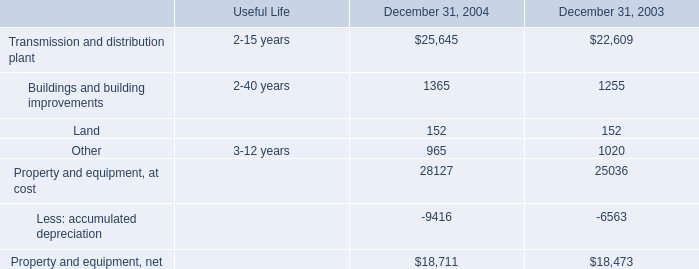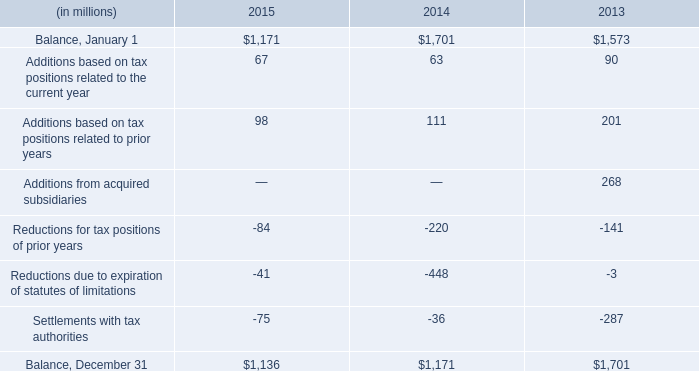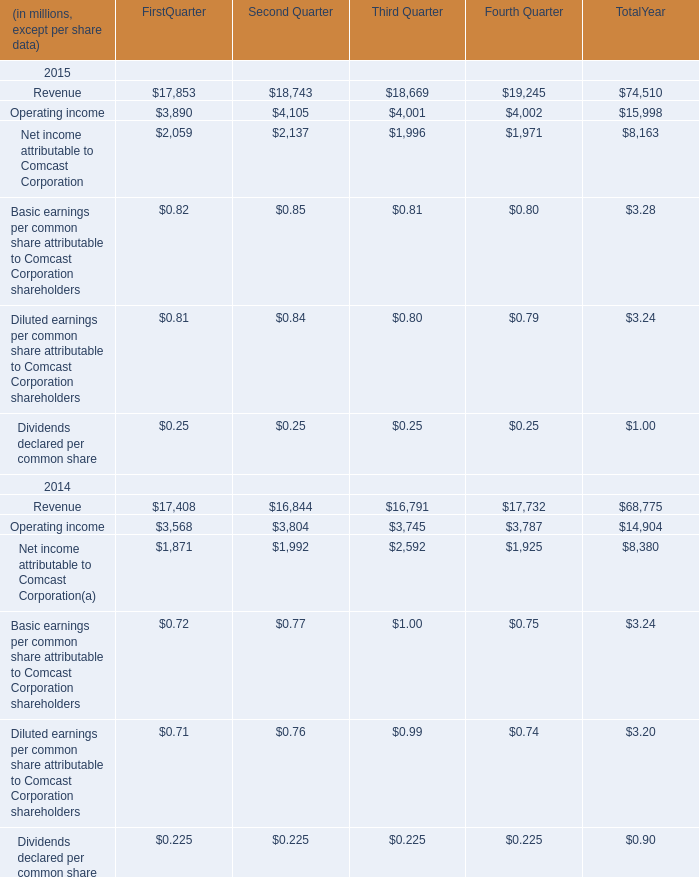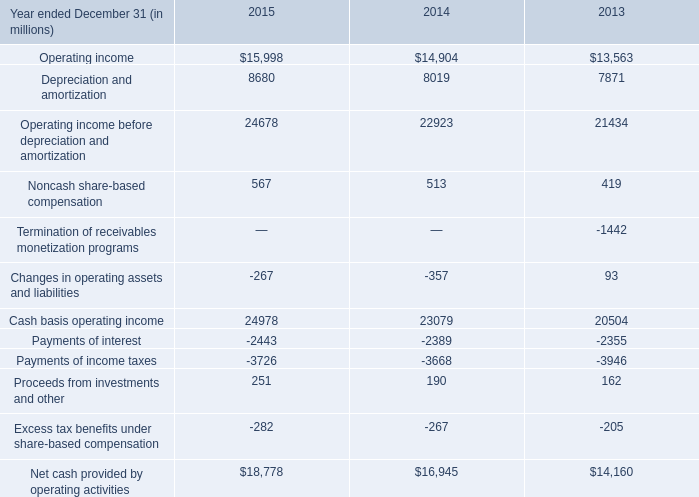What is the sum of Payments of interest of 2013, and Other of December 31, 2003 ? 
Computations: (2355.0 + 1020.0)
Answer: 3375.0. 